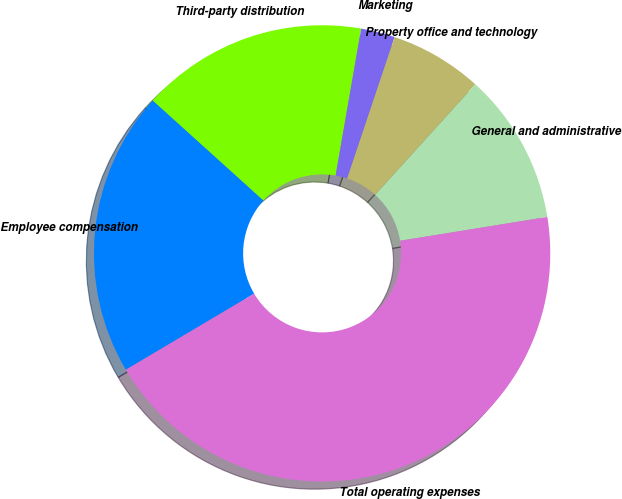<chart> <loc_0><loc_0><loc_500><loc_500><pie_chart><fcel>Employee compensation<fcel>Third-party distribution<fcel>Marketing<fcel>Property office and technology<fcel>General and administrative<fcel>Total operating expenses<nl><fcel>20.21%<fcel>16.05%<fcel>2.41%<fcel>6.57%<fcel>10.73%<fcel>44.04%<nl></chart> 